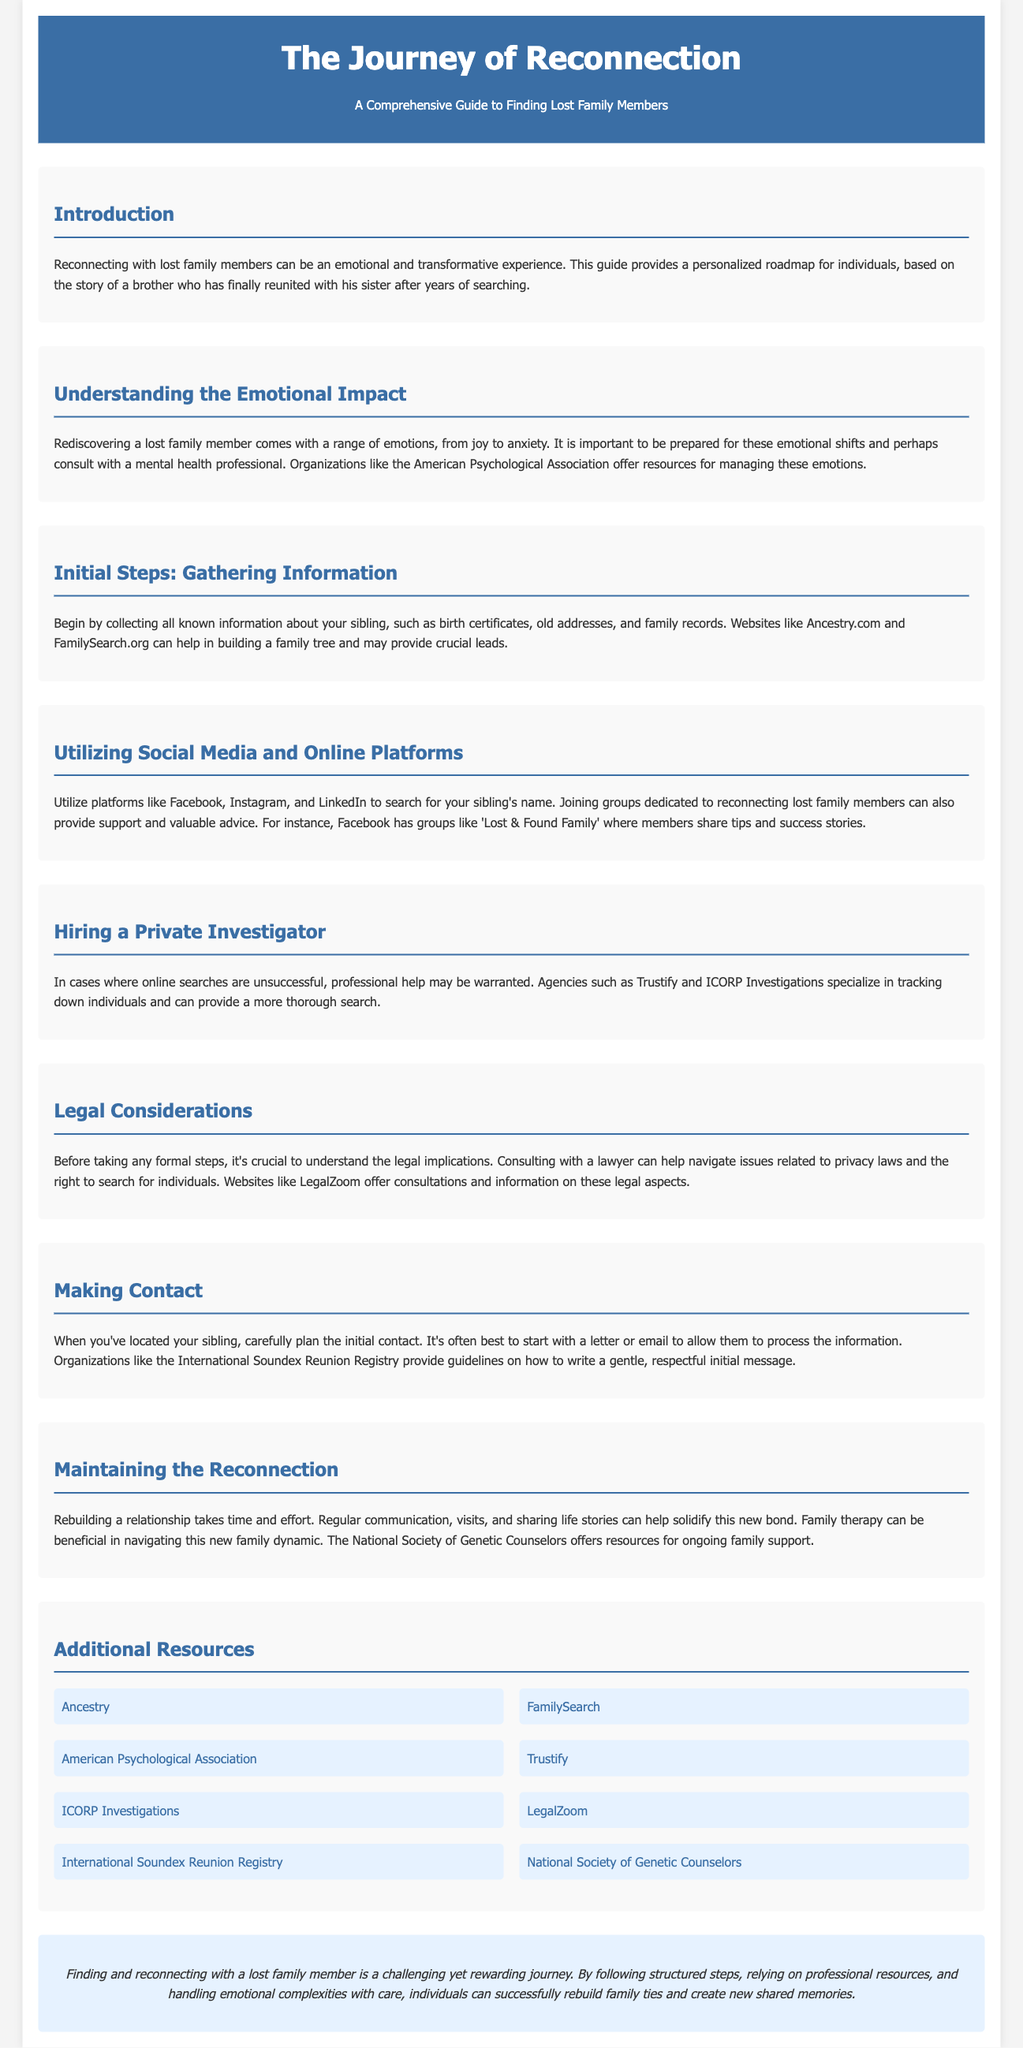What is the title of the document? The title of the document is presented in the header section, describing the main focus of the guide.
Answer: The Journey of Reconnection: A Comprehensive Guide to Finding Lost Family Members What organization offers resources for managing emotions during reconnection? The document mentions an organization that specializes in psychology and provides resources for managing emotions related to family reconnection.
Answer: American Psychological Association What should be collected in the initial steps of finding a sibling? The document outlines the essential information needed to start the search for a lost family member, which includes specific types of documents.
Answer: Birth certificates, old addresses, family records Which online platforms are suggested for searching for lost family members? The document lists platforms suitable for searching for someone's name and joining supportive communities.
Answer: Facebook, Instagram, and LinkedIn What type of professional help may be needed if online searches fail? The document mentions a specific category of professionals to contact if initial search efforts are unsuccessful.
Answer: Private Investigator What does the guide suggest for first contact with a sibling? The document advises a specific method for initiating contact with the discovered sibling to facilitate a thoughtful approach.
Answer: Letter or email Which organization provides guidelines for writing an initial message? The document refers to an organization that specializes in helping individuals reconnect and provides writing guidelines.
Answer: International Soundex Reunion Registry What does the document recommend for maintaining the reconnection? The document emphasizes the importance of a specific activity to help solidify the new family bond after reunion.
Answer: Regular communication, visits, sharing life stories What is a critical aspect of legal considerations before searching for a lost family member? The document highlights the importance of understanding legal implications regarding privacy laws, which should be navigated with a professional.
Answer: Consulting with a lawyer 